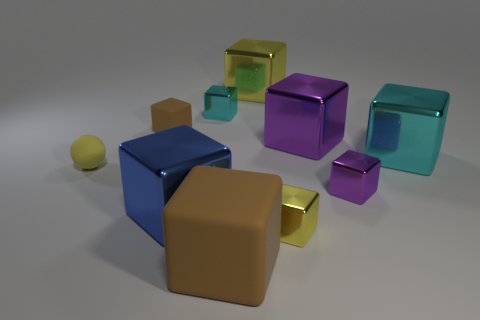Subtract all brown matte blocks. How many blocks are left? 7 Subtract all purple balls. How many purple blocks are left? 2 Subtract all yellow blocks. How many blocks are left? 7 Subtract all cubes. How many objects are left? 1 Subtract all big yellow objects. Subtract all yellow matte balls. How many objects are left? 8 Add 4 large blue things. How many large blue things are left? 5 Add 1 big cylinders. How many big cylinders exist? 1 Subtract 0 gray cylinders. How many objects are left? 10 Subtract all purple blocks. Subtract all cyan cylinders. How many blocks are left? 7 